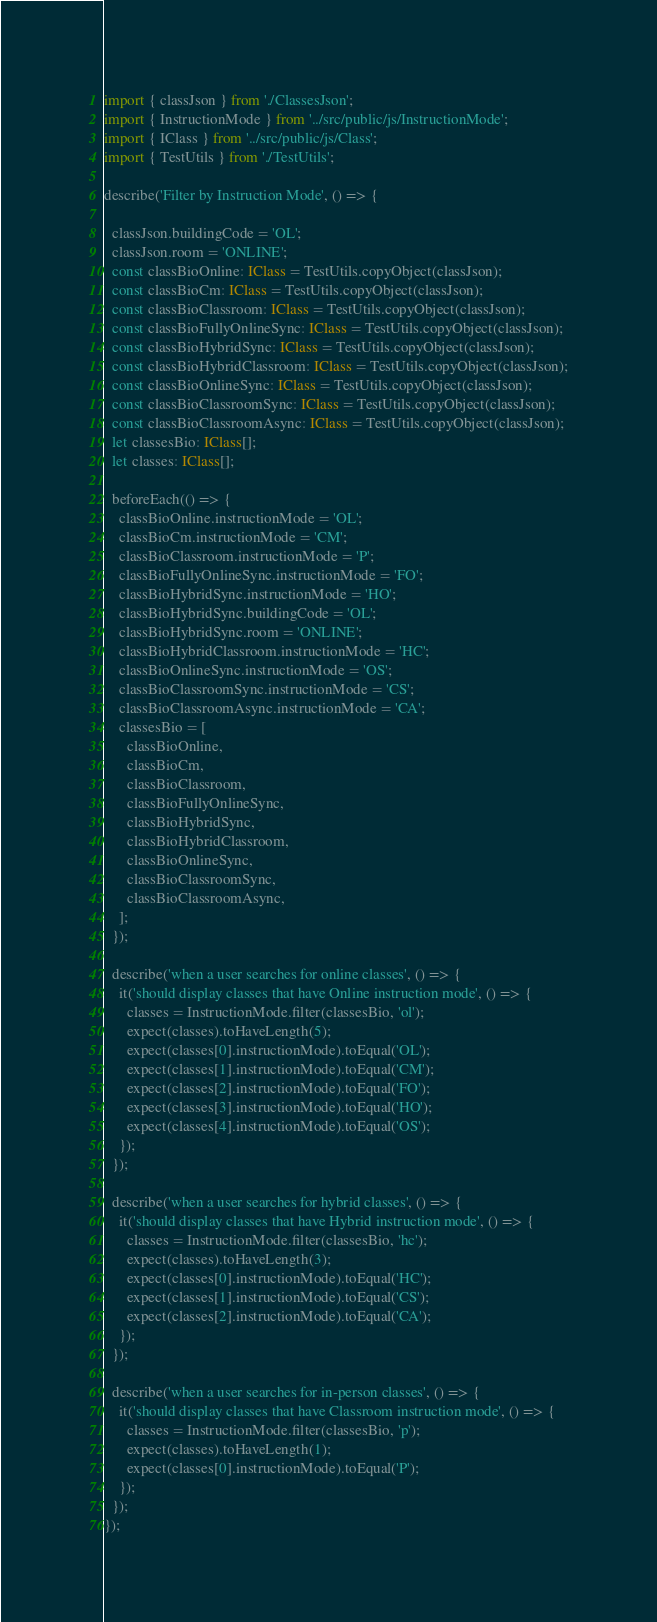Convert code to text. <code><loc_0><loc_0><loc_500><loc_500><_TypeScript_>import { classJson } from './ClassesJson';
import { InstructionMode } from '../src/public/js/InstructionMode';
import { IClass } from '../src/public/js/Class';
import { TestUtils } from './TestUtils';

describe('Filter by Instruction Mode', () => {

  classJson.buildingCode = 'OL';
  classJson.room = 'ONLINE';
  const classBioOnline: IClass = TestUtils.copyObject(classJson);
  const classBioCm: IClass = TestUtils.copyObject(classJson);
  const classBioClassroom: IClass = TestUtils.copyObject(classJson);
  const classBioFullyOnlineSync: IClass = TestUtils.copyObject(classJson);
  const classBioHybridSync: IClass = TestUtils.copyObject(classJson);
  const classBioHybridClassroom: IClass = TestUtils.copyObject(classJson);
  const classBioOnlineSync: IClass = TestUtils.copyObject(classJson);
  const classBioClassroomSync: IClass = TestUtils.copyObject(classJson);
  const classBioClassroomAsync: IClass = TestUtils.copyObject(classJson);
  let classesBio: IClass[];
  let classes: IClass[];

  beforeEach(() => {
    classBioOnline.instructionMode = 'OL';
    classBioCm.instructionMode = 'CM';
    classBioClassroom.instructionMode = 'P';
    classBioFullyOnlineSync.instructionMode = 'FO';
    classBioHybridSync.instructionMode = 'HO';
    classBioHybridSync.buildingCode = 'OL';
    classBioHybridSync.room = 'ONLINE';
    classBioHybridClassroom.instructionMode = 'HC';
    classBioOnlineSync.instructionMode = 'OS';
    classBioClassroomSync.instructionMode = 'CS';
    classBioClassroomAsync.instructionMode = 'CA';
    classesBio = [
      classBioOnline,
      classBioCm,
      classBioClassroom,
      classBioFullyOnlineSync,
      classBioHybridSync,
      classBioHybridClassroom,
      classBioOnlineSync,
      classBioClassroomSync,
      classBioClassroomAsync,
    ];
  });

  describe('when a user searches for online classes', () => {
    it('should display classes that have Online instruction mode', () => {
      classes = InstructionMode.filter(classesBio, 'ol');
      expect(classes).toHaveLength(5);
      expect(classes[0].instructionMode).toEqual('OL');
      expect(classes[1].instructionMode).toEqual('CM');
      expect(classes[2].instructionMode).toEqual('FO');
      expect(classes[3].instructionMode).toEqual('HO');
      expect(classes[4].instructionMode).toEqual('OS');
    });
  });

  describe('when a user searches for hybrid classes', () => {
    it('should display classes that have Hybrid instruction mode', () => {
      classes = InstructionMode.filter(classesBio, 'hc');
      expect(classes).toHaveLength(3);
      expect(classes[0].instructionMode).toEqual('HC');
      expect(classes[1].instructionMode).toEqual('CS');
      expect(classes[2].instructionMode).toEqual('CA');
    });
  });

  describe('when a user searches for in-person classes', () => {
    it('should display classes that have Classroom instruction mode', () => {
      classes = InstructionMode.filter(classesBio, 'p');
      expect(classes).toHaveLength(1);
      expect(classes[0].instructionMode).toEqual('P');
    });
  });
});
</code> 